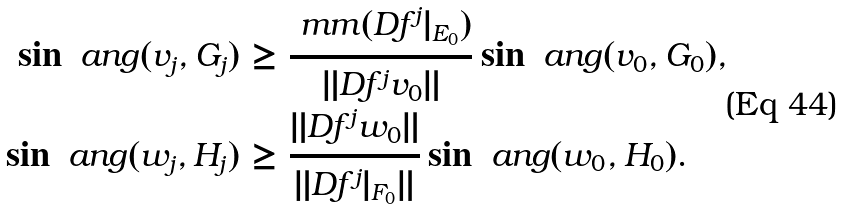<formula> <loc_0><loc_0><loc_500><loc_500>\sin \ a n g ( v _ { j } , G _ { j } ) & \geq \frac { \ m m ( D f ^ { j } | _ { E _ { 0 } } ) } { \| D f ^ { j } v _ { 0 } \| } \sin \ a n g ( v _ { 0 } , G _ { 0 } ) , \\ \sin \ a n g ( w _ { j } , H _ { j } ) & \geq \frac { \| D f ^ { j } w _ { 0 } \| } { \| D f ^ { j } | _ { F _ { 0 } } \| } \sin \ a n g ( w _ { 0 } , H _ { 0 } ) .</formula> 